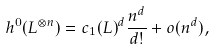<formula> <loc_0><loc_0><loc_500><loc_500>h ^ { 0 } ( L ^ { \otimes n } ) = c _ { 1 } ( L ) ^ { d } \frac { n ^ { d } } { d ! } + o ( n ^ { d } ) ,</formula> 